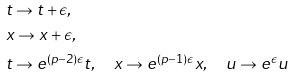<formula> <loc_0><loc_0><loc_500><loc_500>& t \rightarrow t + \epsilon , \\ & x \rightarrow x + \epsilon , \\ & t \rightarrow e ^ { ( p - 2 ) \epsilon } t , \quad x \rightarrow e ^ { ( p - 1 ) \epsilon } x , \quad u \rightarrow e ^ { \epsilon } u</formula> 